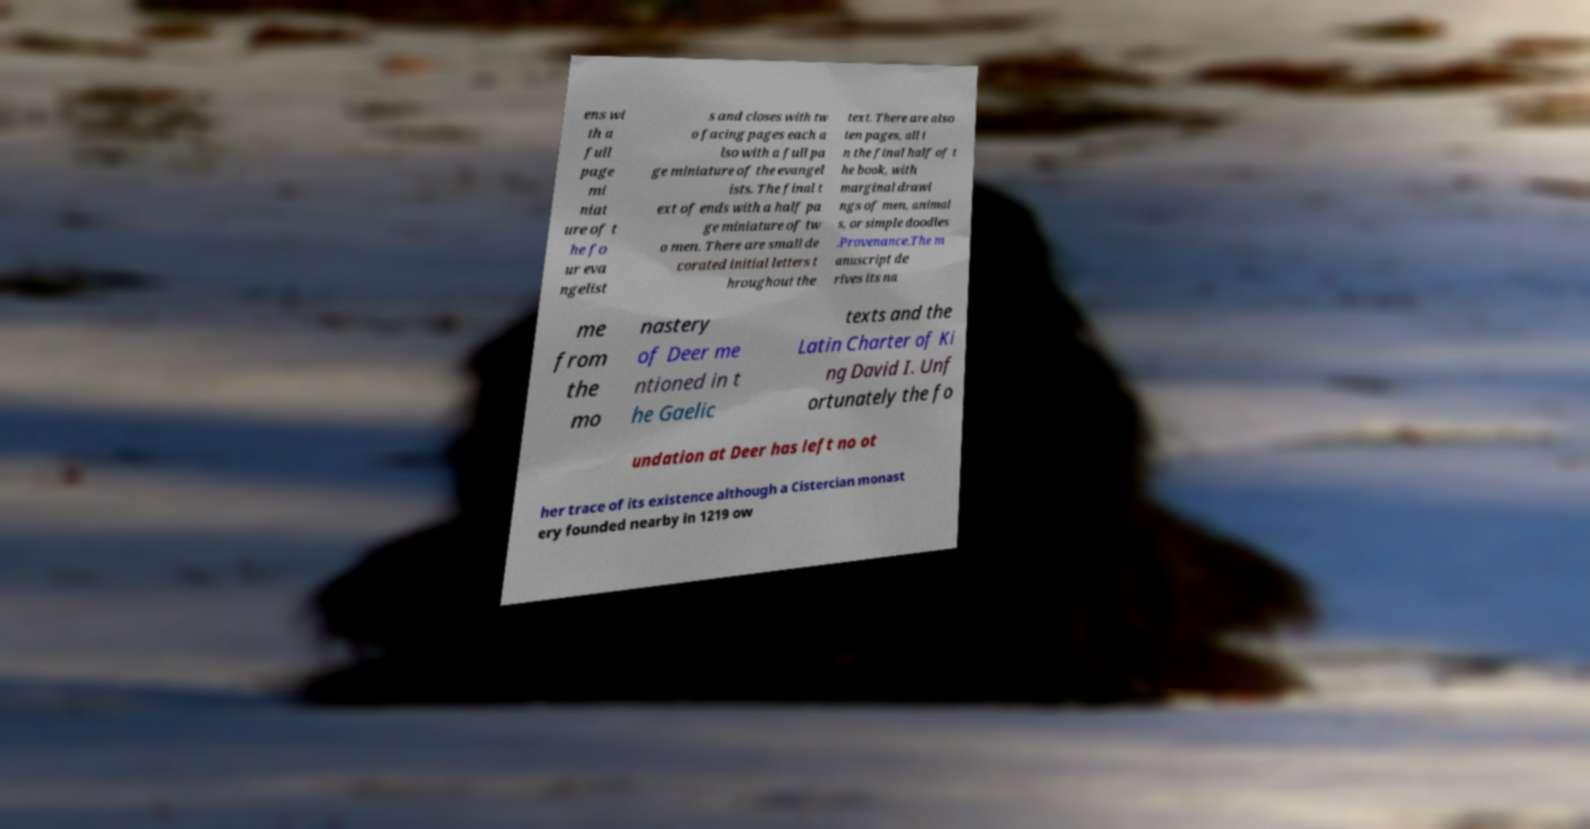Please read and relay the text visible in this image. What does it say? ens wi th a full page mi niat ure of t he fo ur eva ngelist s and closes with tw o facing pages each a lso with a full pa ge miniature of the evangel ists. The final t ext of ends with a half pa ge miniature of tw o men. There are small de corated initial letters t hroughout the text. There are also ten pages, all i n the final half of t he book, with marginal drawi ngs of men, animal s, or simple doodles .Provenance.The m anuscript de rives its na me from the mo nastery of Deer me ntioned in t he Gaelic texts and the Latin Charter of Ki ng David I. Unf ortunately the fo undation at Deer has left no ot her trace of its existence although a Cistercian monast ery founded nearby in 1219 ow 